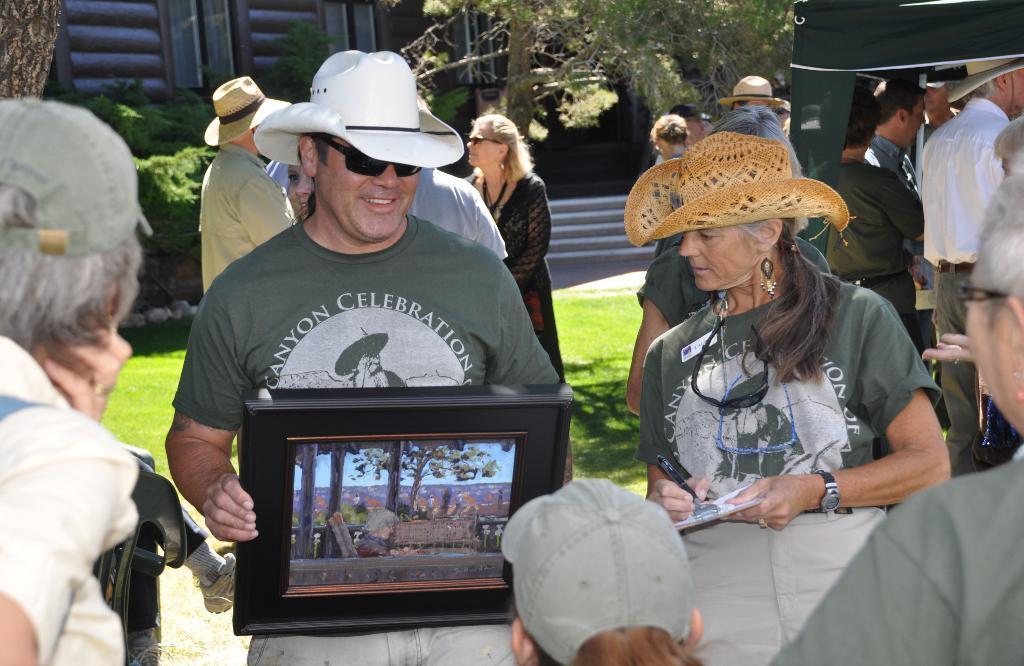Could you give a brief overview of what you see in this image? Here in this picture in the middle we can see a person standing on the ground over there and he is holding something in his hand and he is smiling and wearing goggles and hat on him and beside him also we can see another woman standing and writing something in the paper present in her hand and wearing hat on her and we can also see other people standing over there and we can see some part of ground is covered with grass and we can see plants and trees present over there. 